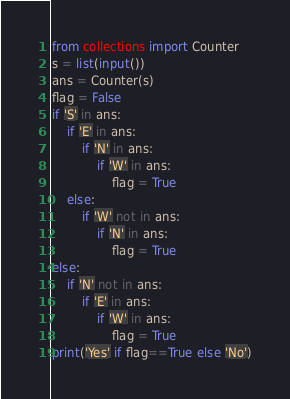Convert code to text. <code><loc_0><loc_0><loc_500><loc_500><_Python_>from collections import Counter
s = list(input())
ans = Counter(s)
flag = False
if 'S' in ans:
    if 'E' in ans:
        if 'N' in ans:
            if 'W' in ans:
                flag = True
    else:
        if 'W' not in ans:
            if 'N' in ans:
                flag = True
else:
    if 'N' not in ans:
        if 'E' in ans:
            if 'W' in ans:
                flag = True
print('Yes' if flag==True else 'No')</code> 